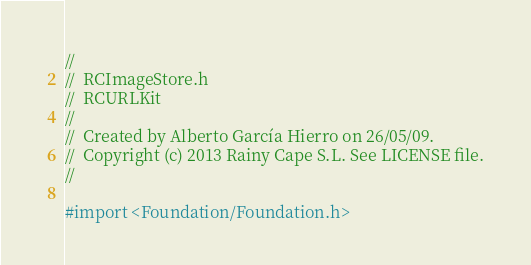Convert code to text. <code><loc_0><loc_0><loc_500><loc_500><_C_>//
//  RCImageStore.h
//  RCURLKit
//
//  Created by Alberto García Hierro on 26/05/09.
//  Copyright (c) 2013 Rainy Cape S.L. See LICENSE file.
//

#import <Foundation/Foundation.h>
</code> 